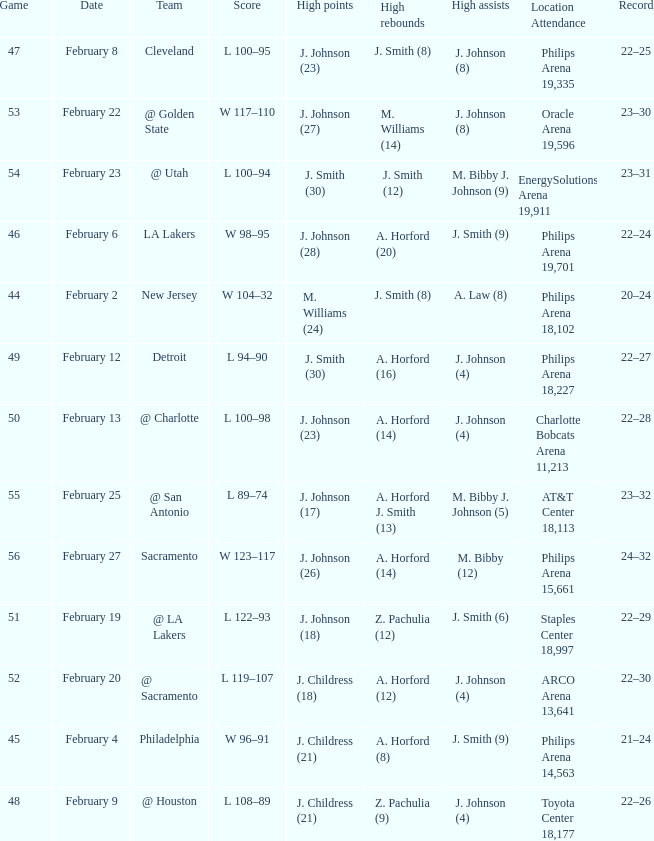Name the number of teams at the philips arena 19,335? 1.0. 